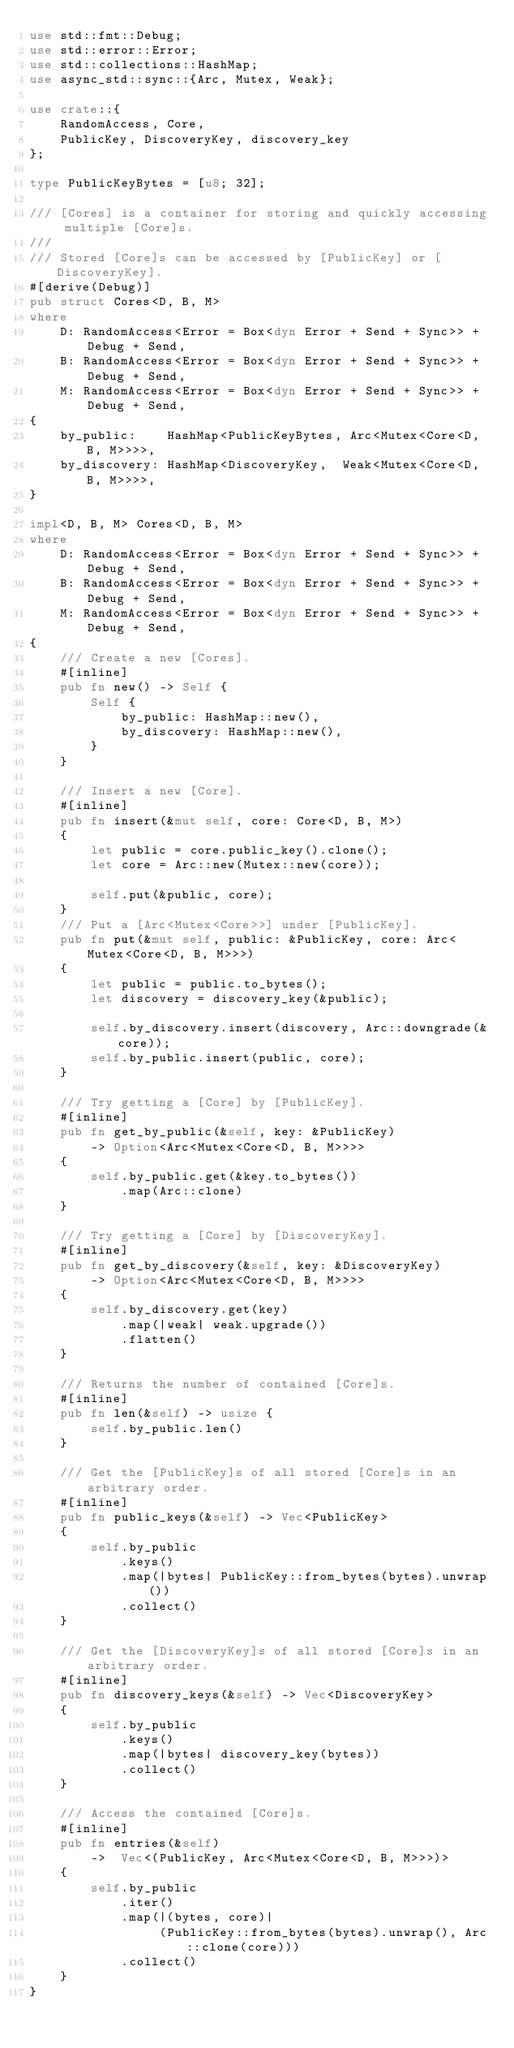Convert code to text. <code><loc_0><loc_0><loc_500><loc_500><_Rust_>use std::fmt::Debug;
use std::error::Error;
use std::collections::HashMap;
use async_std::sync::{Arc, Mutex, Weak};

use crate::{
    RandomAccess, Core,
    PublicKey, DiscoveryKey, discovery_key
};

type PublicKeyBytes = [u8; 32];

/// [Cores] is a container for storing and quickly accessing multiple [Core]s.
///
/// Stored [Core]s can be accessed by [PublicKey] or [DiscoveryKey].
#[derive(Debug)]
pub struct Cores<D, B, M>
where
    D: RandomAccess<Error = Box<dyn Error + Send + Sync>> + Debug + Send,
    B: RandomAccess<Error = Box<dyn Error + Send + Sync>> + Debug + Send,
    M: RandomAccess<Error = Box<dyn Error + Send + Sync>> + Debug + Send,
{
    by_public:    HashMap<PublicKeyBytes, Arc<Mutex<Core<D, B, M>>>>,
    by_discovery: HashMap<DiscoveryKey,  Weak<Mutex<Core<D, B, M>>>>,
}

impl<D, B, M> Cores<D, B, M>
where
    D: RandomAccess<Error = Box<dyn Error + Send + Sync>> + Debug + Send,
    B: RandomAccess<Error = Box<dyn Error + Send + Sync>> + Debug + Send,
    M: RandomAccess<Error = Box<dyn Error + Send + Sync>> + Debug + Send,
{
    /// Create a new [Cores].
    #[inline]
    pub fn new() -> Self {
        Self {
            by_public: HashMap::new(),
            by_discovery: HashMap::new(),
        }
    }

    /// Insert a new [Core].
    #[inline]
    pub fn insert(&mut self, core: Core<D, B, M>)
    {
        let public = core.public_key().clone();
        let core = Arc::new(Mutex::new(core));

        self.put(&public, core);
    }
    /// Put a [Arc<Mutex<Core>>] under [PublicKey].
    pub fn put(&mut self, public: &PublicKey, core: Arc<Mutex<Core<D, B, M>>>)
    {
        let public = public.to_bytes();
        let discovery = discovery_key(&public);

        self.by_discovery.insert(discovery, Arc::downgrade(&core));
        self.by_public.insert(public, core);
    }

    /// Try getting a [Core] by [PublicKey].
    #[inline]
    pub fn get_by_public(&self, key: &PublicKey)
        -> Option<Arc<Mutex<Core<D, B, M>>>>
    {
        self.by_public.get(&key.to_bytes())
            .map(Arc::clone)
    }

    /// Try getting a [Core] by [DiscoveryKey].
    #[inline]
    pub fn get_by_discovery(&self, key: &DiscoveryKey)
        -> Option<Arc<Mutex<Core<D, B, M>>>>
    {
        self.by_discovery.get(key)
            .map(|weak| weak.upgrade())
            .flatten()
    }

    /// Returns the number of contained [Core]s.
    #[inline]
    pub fn len(&self) -> usize {
        self.by_public.len()
    }

    /// Get the [PublicKey]s of all stored [Core]s in an arbitrary order.
    #[inline]
    pub fn public_keys(&self) -> Vec<PublicKey>
    {
        self.by_public
            .keys()
            .map(|bytes| PublicKey::from_bytes(bytes).unwrap())
            .collect()
    }

    /// Get the [DiscoveryKey]s of all stored [Core]s in an arbitrary order.
    #[inline]
    pub fn discovery_keys(&self) -> Vec<DiscoveryKey>
    {
        self.by_public
            .keys()
            .map(|bytes| discovery_key(bytes))
            .collect()
    }

    /// Access the contained [Core]s.
    #[inline]
    pub fn entries(&self)
        ->  Vec<(PublicKey, Arc<Mutex<Core<D, B, M>>>)>
    {
        self.by_public
            .iter()
            .map(|(bytes, core)|
                 (PublicKey::from_bytes(bytes).unwrap(), Arc::clone(core)))
            .collect()
    }
}
</code> 